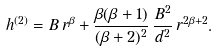<formula> <loc_0><loc_0><loc_500><loc_500>h ^ { ( 2 ) } = B \, r ^ { \beta } + \frac { \beta ( \beta + 1 ) } { ( \beta + 2 ) ^ { 2 } } \, \frac { B ^ { 2 } } { d ^ { 2 } } \, r ^ { 2 \beta + 2 } .</formula> 